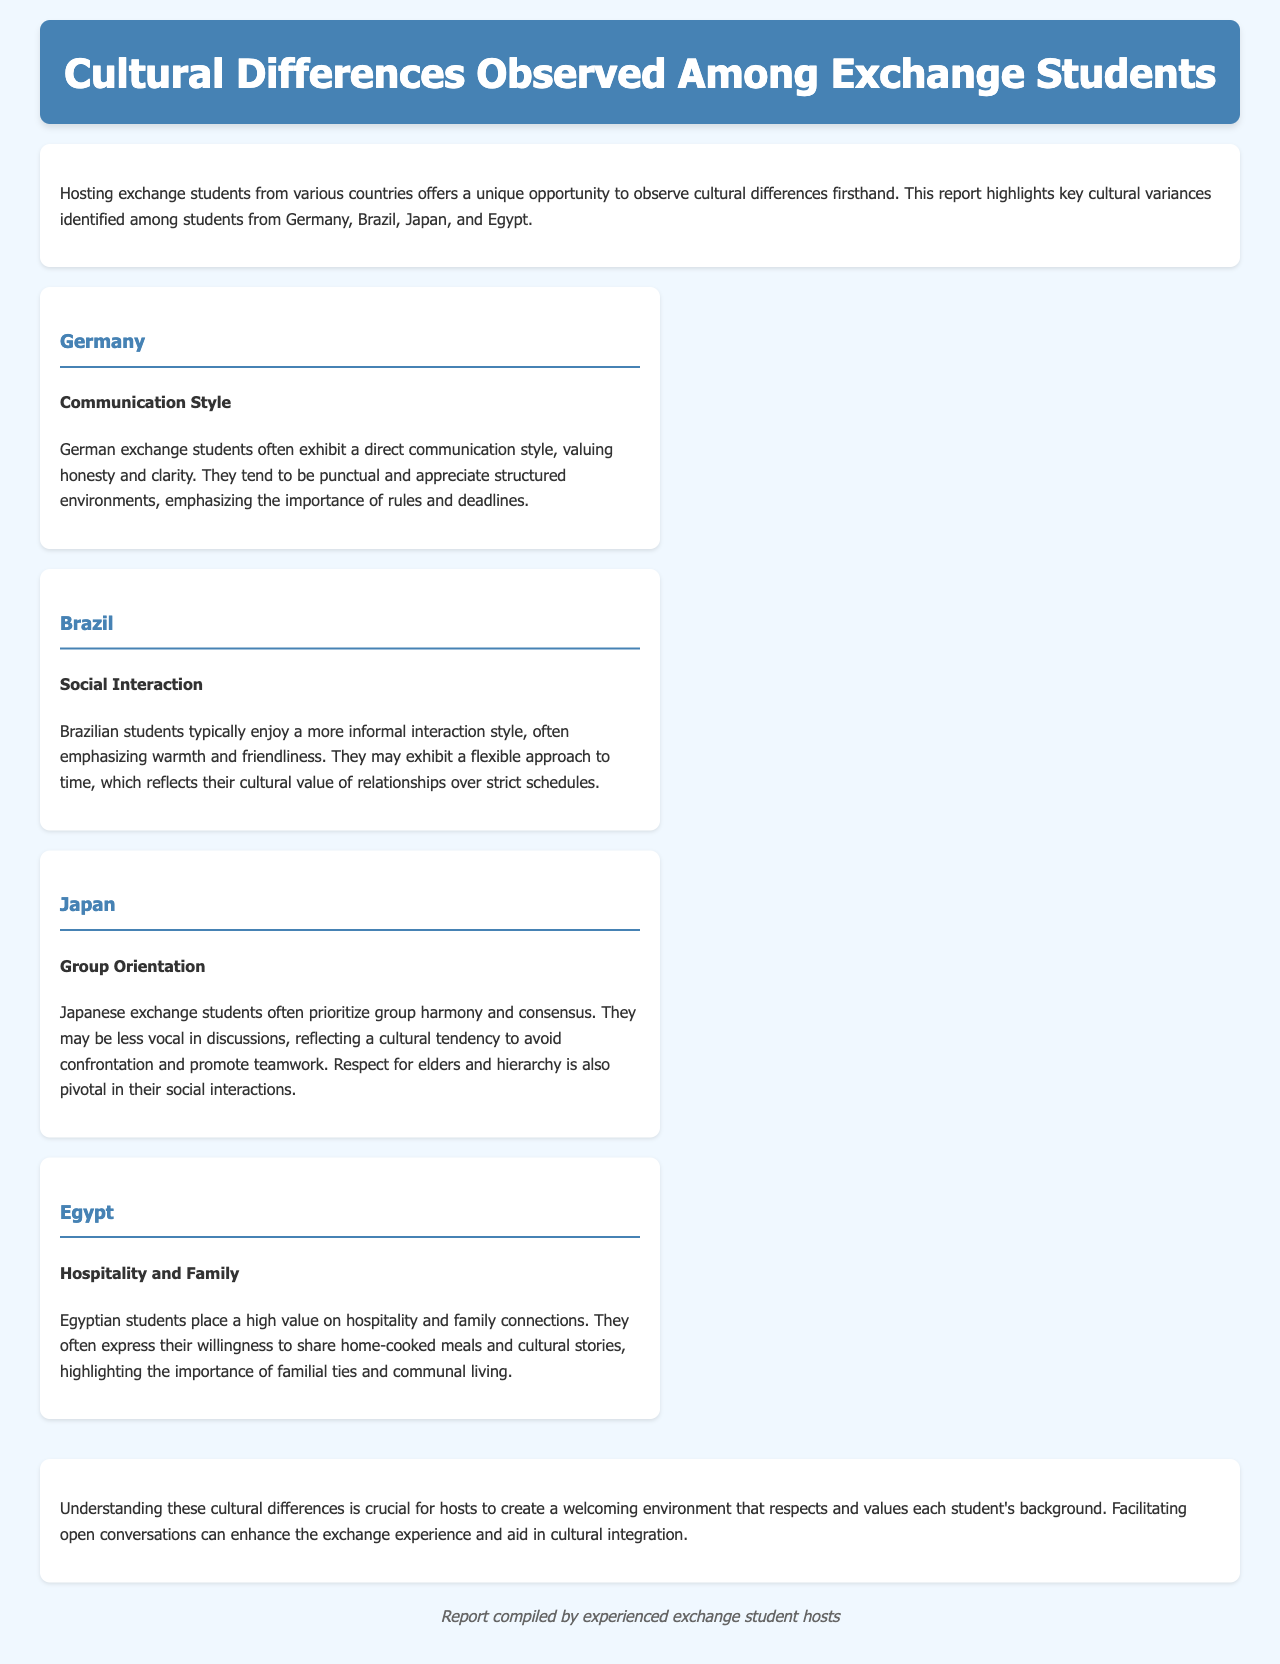What countries are discussed in the report? The report highlights cultural differences among students from Germany, Brazil, Japan, and Egypt.
Answer: Germany, Brazil, Japan, Egypt What is a key characteristic of German communication style? German exchange students often exhibit a direct communication style, valuing honesty and clarity.
Answer: Direct How do Brazilian students typically approach social interactions? Brazilian students enjoy a more informal interaction style, emphasizing warmth and friendliness.
Answer: Informal What is a priority for Japanese exchange students in social settings? Japanese exchange students often prioritize group harmony and consensus.
Answer: Group harmony What is highly valued by Egyptian students according to the report? Egyptian students place a high value on hospitality and family connections.
Answer: Hospitality and family How many countries are specifically mentioned in the cultural differences section? There are four countries specifically mentioned in the cultural differences section.
Answer: Four What does the report suggest is crucial for hosts in understanding cultural differences? Understanding these cultural differences is crucial for hosts to create a welcoming environment.
Answer: Create a welcoming environment Which cultural aspect is emphasized in both Brazilian and Egyptian students? Both Brazilian and Egyptian students emphasize the importance of relationships in their interactions.
Answer: Importance of relationships 